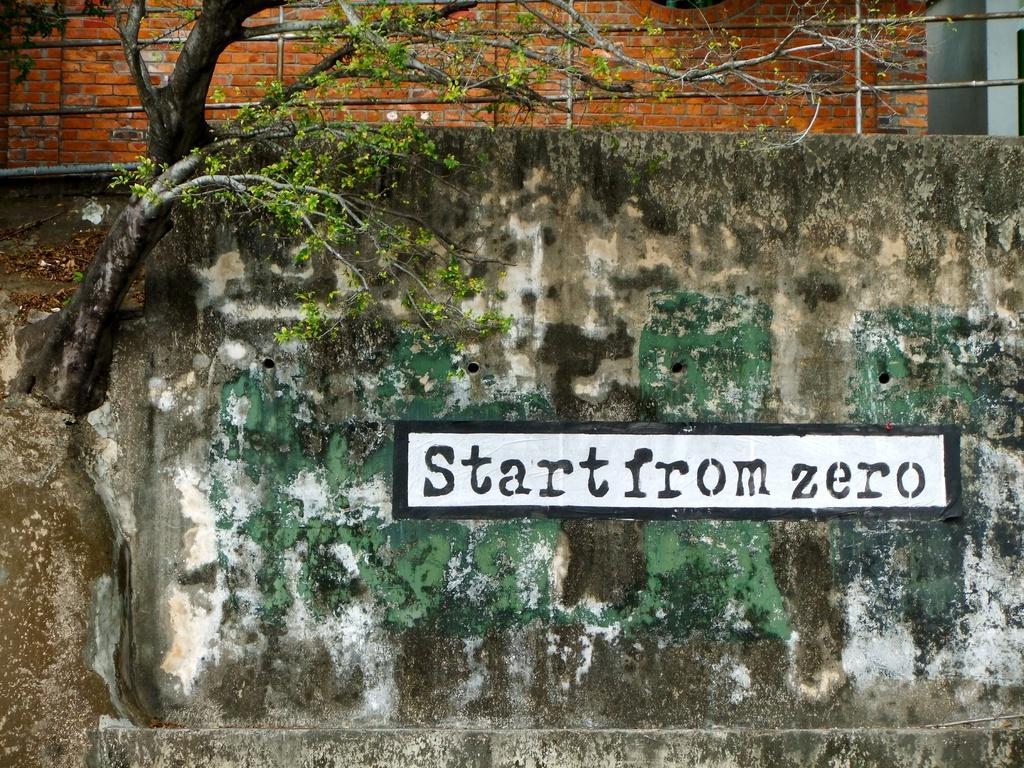In one or two sentences, can you explain what this image depicts? In this image we can see the walls, grille, tree, also we can see some text on the wall. 